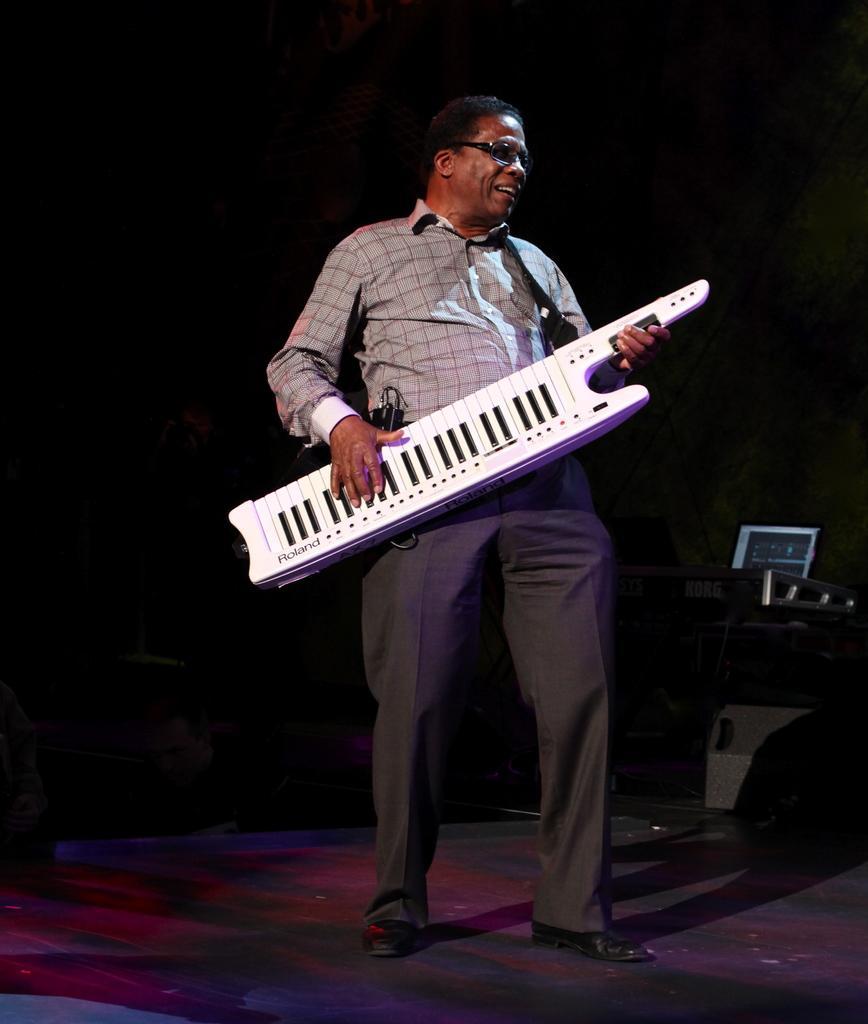Can you describe this image briefly? In the foreground of this image, there is a man standing and playing keytar and the objects in the dark background. 